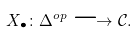Convert formula to latex. <formula><loc_0><loc_0><loc_500><loc_500>X _ { \bullet } \colon \Delta ^ { o p } \longrightarrow \mathcal { C } .</formula> 